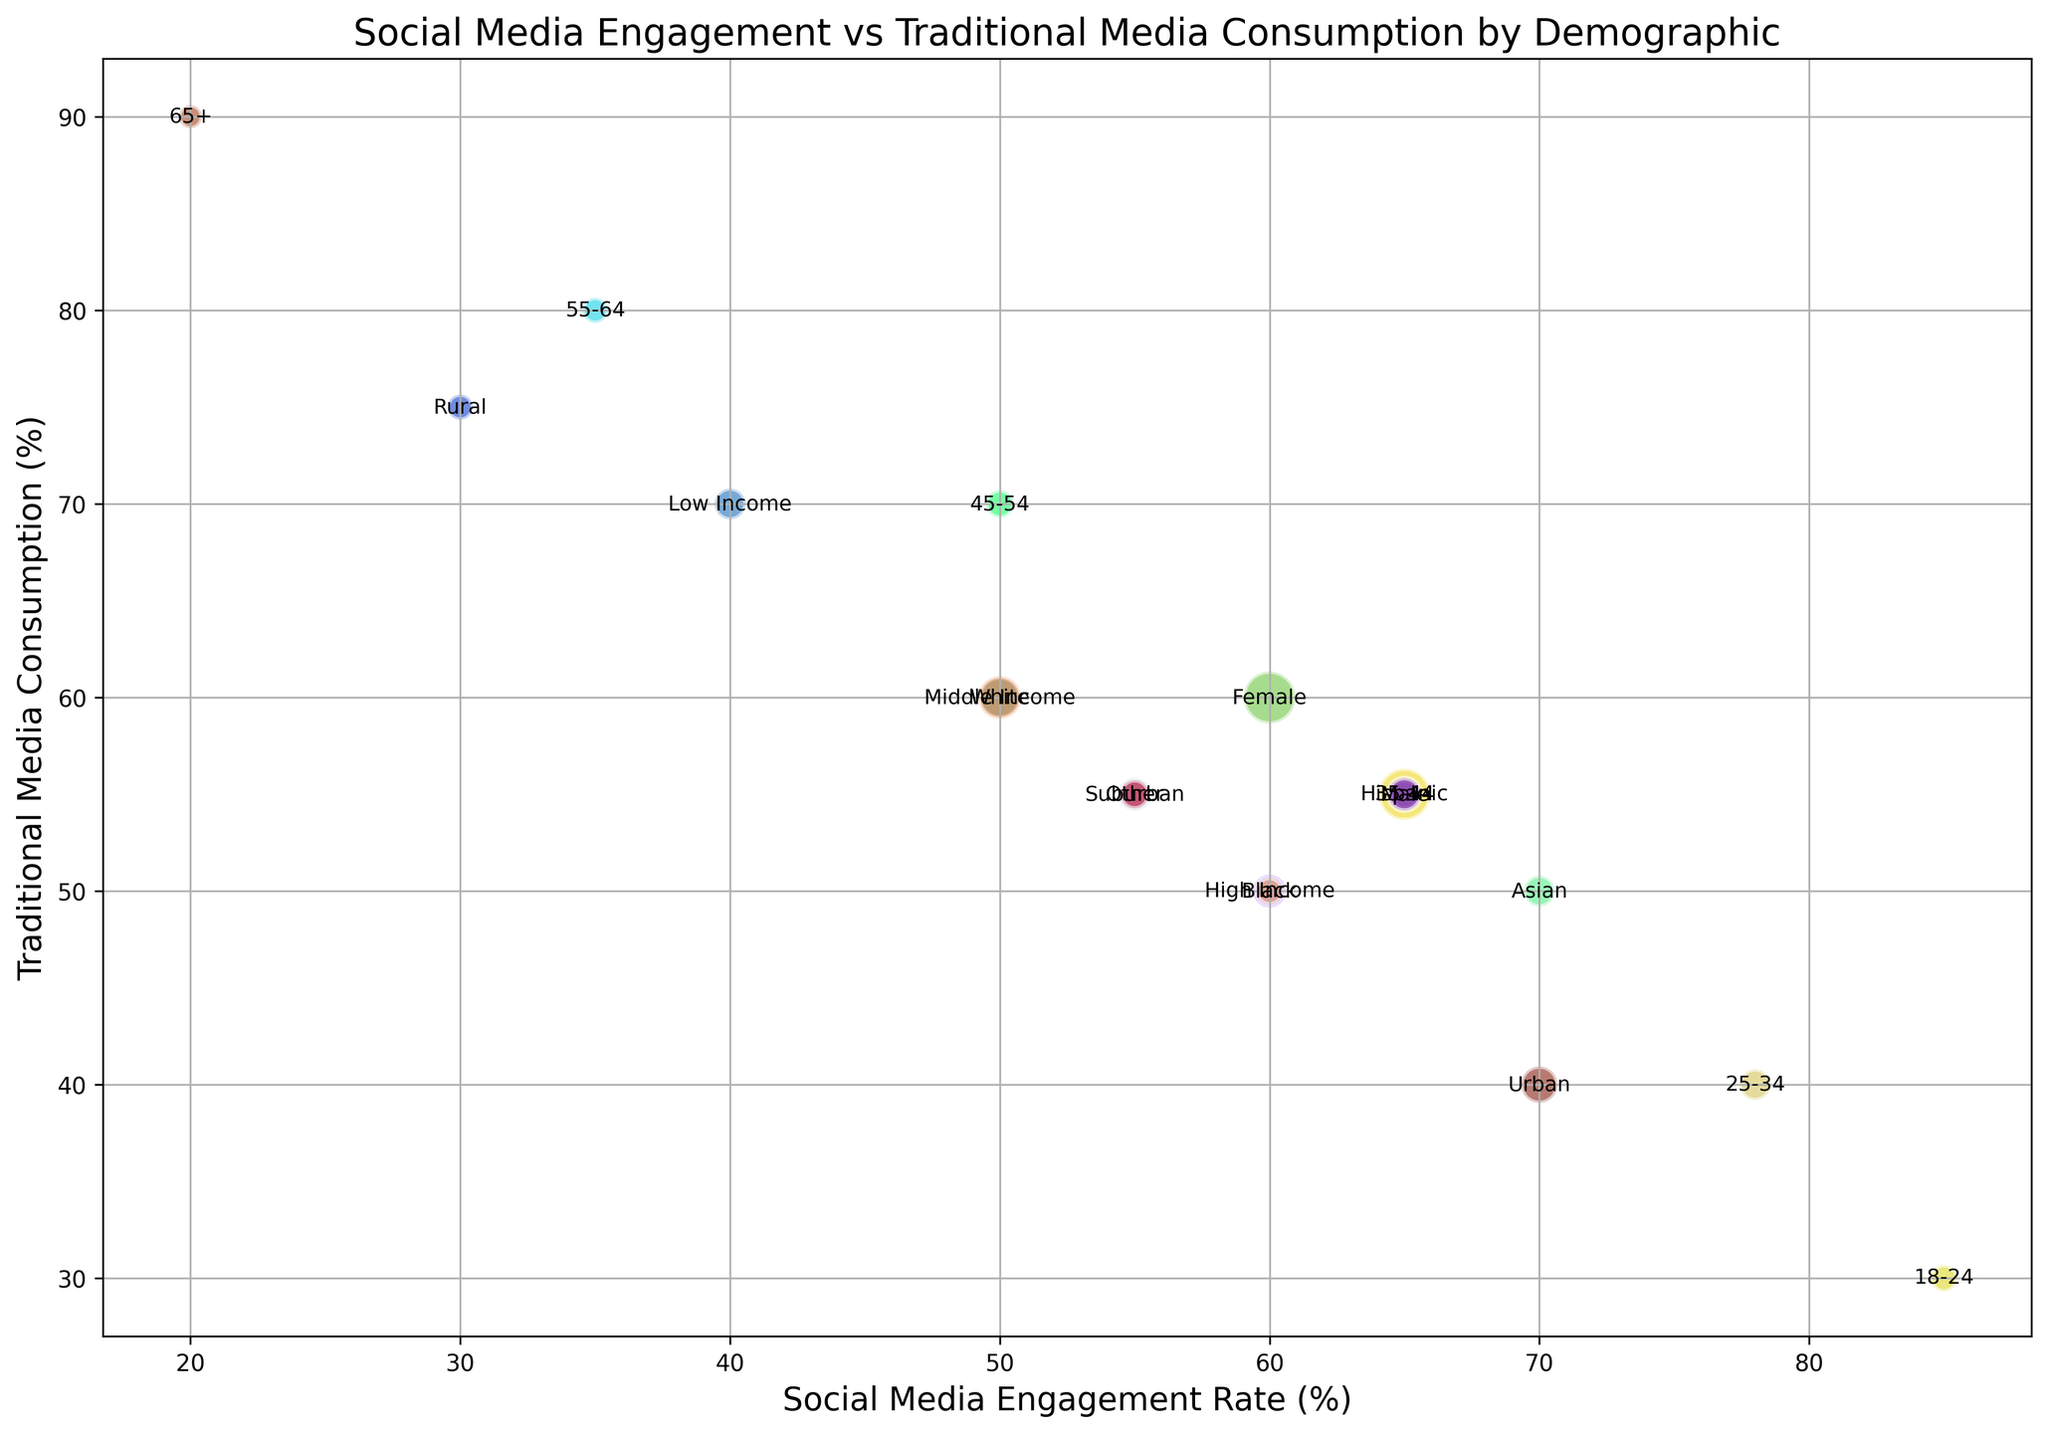What demographic has the highest Social Media Engagement Rate? The demographic data point with the highest y-value (Social Media Engagement Rate) is identified as '18-24' with a rate of 85%.
Answer: 18-24 Which demographic shows the highest consumption of Traditional Media? The demographic data point with the highest Traditional Media Consumption is identified as '65+' with a rate of 90%.
Answer: 65+ What is the difference between the Social Media Engagement Rates of the '18-24' and the '65+' demographics? The '18-24' demographic has an engagement rate of 85% and the '65+' demographic has 20%. The difference is 85% - 20% = 65%.
Answer: 65% Which income group has the highest Social Media Engagement Rate? The 'High Income' group has the highest Social Media Engagement Rate among income groups, showing a rate of 60%.
Answer: High Income Which demographic has the largest population size? The largest bubble, representing the largest population, corresponds to the 'Female' demographic with a population of 51,000,000.
Answer: Female What is the average Traditional Media Consumption rate for male and female demographics combined? The Traditional Media Consumption rate for Males is 55% and for Females is 60%. The average is (55% + 60%) / 2 = 57.5%.
Answer: 57.5% Which demographic has a higher Traditional Media Consumption rate, 'Urban' or 'Rural'? The 'Rural' demographic has a higher Traditional Media Consumption rate of 75%, compared to 'Urban' with 40%.
Answer: Rural What is the sum of the Social Media Engagement Rates for all age groups from '18-24' to '65+'? Summing the Social Media Engagement Rates for '18-24' (85%), '25-34' (78%), '35-44' (65%), '45-54' (50%), '55-64' (35%), and '65+' (20%): 85 + 78 + 65 + 50 + 35 + 20 = 333%.
Answer: 333% Which demographic group lies closest to the intersection of Social Media Engagement Rate of 55% and Traditional Media Consumption rate of 55%? The 'Other' demographic is closest to this intersection, possessing values of exactly 55% in both categories.
Answer: Other Among 'High Income', 'Middle Income', and 'Low Income' groups, which has the lowest Traditional Media Consumption? The 'High Income' group has the lowest Traditional Media Consumption rate of 50% among the income groups.
Answer: High Income 